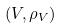Convert formula to latex. <formula><loc_0><loc_0><loc_500><loc_500>( V , \rho _ { V } )</formula> 